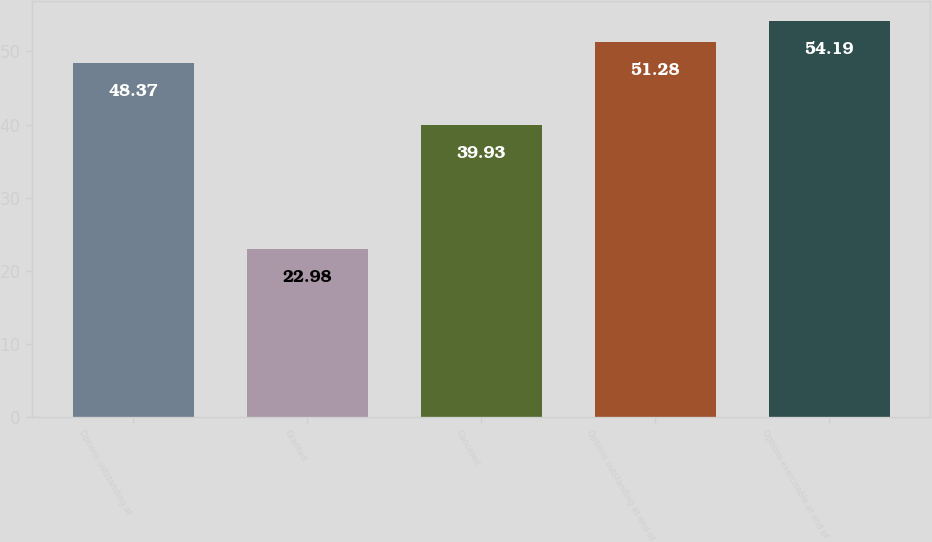<chart> <loc_0><loc_0><loc_500><loc_500><bar_chart><fcel>Options outstanding at<fcel>Granted<fcel>Canceled<fcel>Options outstanding at end of<fcel>Options exercisable at end of<nl><fcel>48.37<fcel>22.98<fcel>39.93<fcel>51.28<fcel>54.19<nl></chart> 